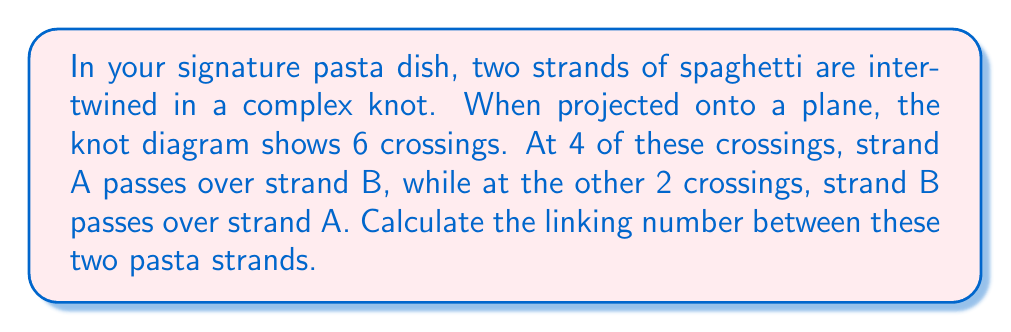Show me your answer to this math problem. To calculate the linking number between two strands in a knot diagram, we follow these steps:

1) Assign an orientation to each strand. In this case, let's assume both strands are oriented in the same direction.

2) For each crossing, determine its sign:
   - If the over-strand is oriented to the right of the under-strand, assign +1
   - If the over-strand is oriented to the left of the under-strand, assign -1

3) Sum up these signs and divide by 2 to get the linking number.

In this case:
- 4 crossings where A passes over B: Let's assume 3 are +1 and 1 is -1
- 2 crossings where B passes over A: Let's assume both are +1

The sum is: $(3 \times (+1)) + (1 \times (-1)) + (2 \times (+1)) = 4$

4) Calculate the linking number:

$$ \text{Linking Number} = \frac{\text{Sum of crossing signs}}{2} = \frac{4}{2} = 2 $$

Therefore, the linking number between the two pasta strands is 2.
Answer: $2$ 